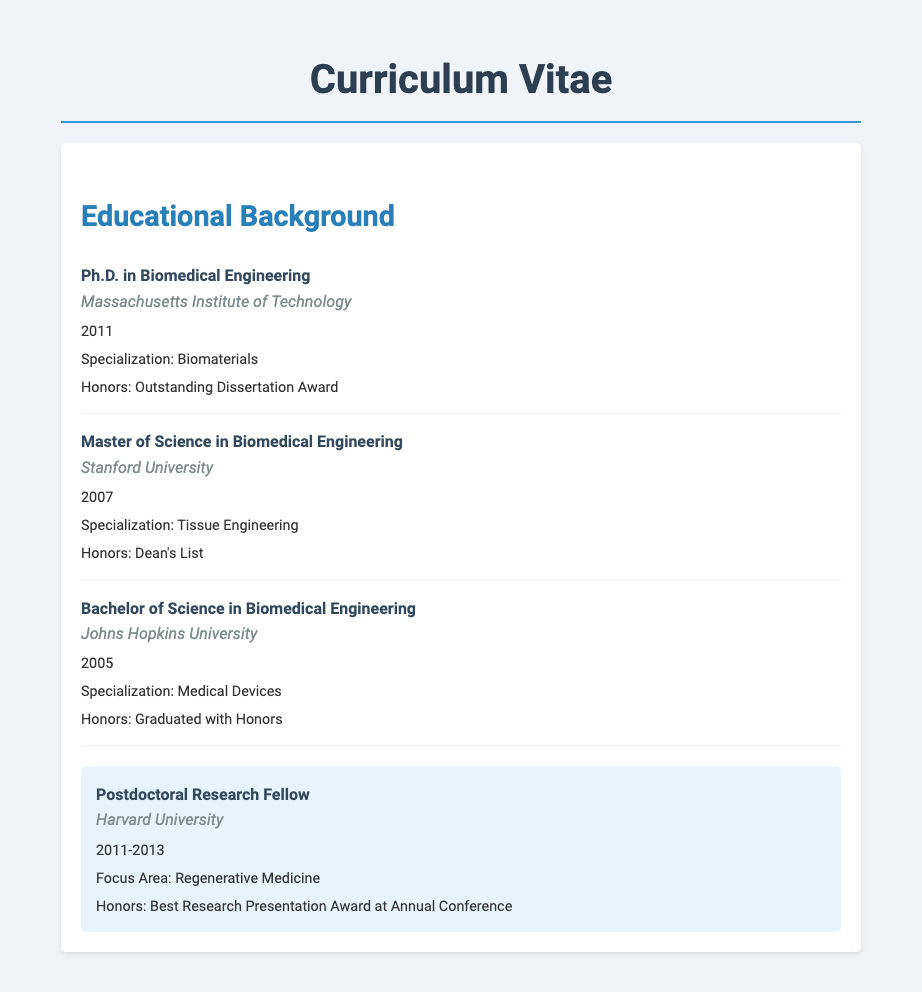What is the highest degree obtained? The highest degree mentioned in the document is a Ph.D., obtained in Biomedical Engineering.
Answer: Ph.D. in Biomedical Engineering Which institution awarded the Bachelor's degree? The Bachelor's degree in Biomedical Engineering was awarded by Johns Hopkins University.
Answer: Johns Hopkins University What year was the Master's degree obtained? The year in which the Master's degree in Biomedical Engineering was obtained is specified in the document.
Answer: 2007 What was the specialization of the Ph.D. degree? The document specifies that the specialization for the Ph.D. is Biomaterials.
Answer: Biomaterials How long was the postdoctoral research fellowship? The duration of the postdoctoral research fellowship is provided as from 2011 to 2013, indicating a length of two years.
Answer: 2 years Which honor did the Master's degree recipient receive? The document states that the honor received for the Master's degree was being on the Dean's List.
Answer: Dean's List What focus area was specified for the postdoctoral work? The focus area during the postdoctoral research fellowship is highlighted as Regenerative Medicine in the document.
Answer: Regenerative Medicine What is the title of the Outstanding Dissertation Award? The Outstanding Dissertation Award is explicitly mentioned as an honor associated with the Ph.D. degree.
Answer: Outstanding Dissertation Award Which university is associated with the postdoctoral research? The document identifies the university where the postdoctoral research was conducted as Harvard University.
Answer: Harvard University 